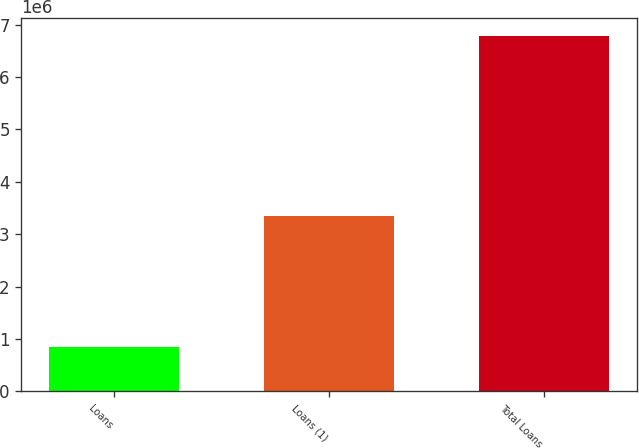Convert chart. <chart><loc_0><loc_0><loc_500><loc_500><bar_chart><fcel>Loans<fcel>Loans (1)<fcel>Total Loans<nl><fcel>851657<fcel>3.34399e+06<fcel>6.78124e+06<nl></chart> 